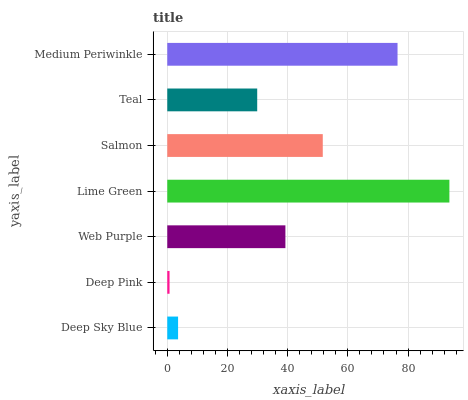Is Deep Pink the minimum?
Answer yes or no. Yes. Is Lime Green the maximum?
Answer yes or no. Yes. Is Web Purple the minimum?
Answer yes or no. No. Is Web Purple the maximum?
Answer yes or no. No. Is Web Purple greater than Deep Pink?
Answer yes or no. Yes. Is Deep Pink less than Web Purple?
Answer yes or no. Yes. Is Deep Pink greater than Web Purple?
Answer yes or no. No. Is Web Purple less than Deep Pink?
Answer yes or no. No. Is Web Purple the high median?
Answer yes or no. Yes. Is Web Purple the low median?
Answer yes or no. Yes. Is Teal the high median?
Answer yes or no. No. Is Medium Periwinkle the low median?
Answer yes or no. No. 